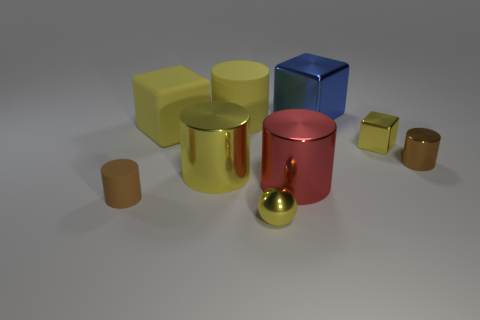Subtract all red cylinders. How many cylinders are left? 4 Subtract all gray cubes. How many brown cylinders are left? 2 Subtract all red cylinders. How many cylinders are left? 4 Subtract all cylinders. How many objects are left? 4 Subtract all green blocks. Subtract all brown cylinders. How many blocks are left? 3 Subtract all tiny metallic balls. Subtract all red cylinders. How many objects are left? 7 Add 3 blocks. How many blocks are left? 6 Add 4 yellow blocks. How many yellow blocks exist? 6 Subtract 2 brown cylinders. How many objects are left? 7 